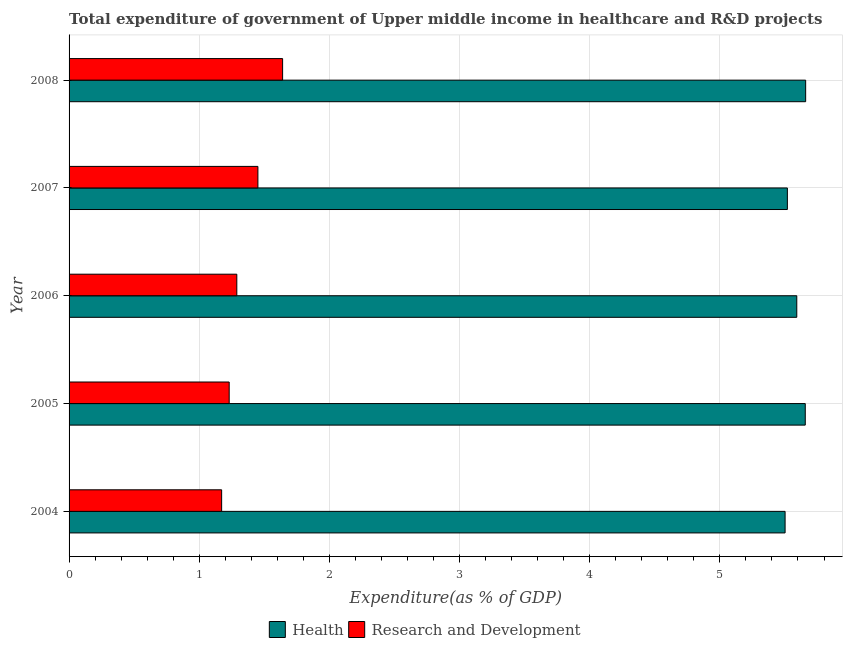Are the number of bars on each tick of the Y-axis equal?
Your answer should be compact. Yes. How many bars are there on the 3rd tick from the bottom?
Ensure brevity in your answer.  2. What is the expenditure in healthcare in 2006?
Ensure brevity in your answer.  5.59. Across all years, what is the maximum expenditure in r&d?
Offer a very short reply. 1.64. Across all years, what is the minimum expenditure in healthcare?
Give a very brief answer. 5.5. What is the total expenditure in r&d in the graph?
Ensure brevity in your answer.  6.78. What is the difference between the expenditure in r&d in 2006 and that in 2007?
Offer a very short reply. -0.16. What is the difference between the expenditure in r&d in 2008 and the expenditure in healthcare in 2007?
Your answer should be compact. -3.88. What is the average expenditure in r&d per year?
Make the answer very short. 1.36. In the year 2008, what is the difference between the expenditure in healthcare and expenditure in r&d?
Your answer should be very brief. 4.02. Is the expenditure in healthcare in 2004 less than that in 2006?
Your answer should be very brief. Yes. Is the difference between the expenditure in r&d in 2004 and 2006 greater than the difference between the expenditure in healthcare in 2004 and 2006?
Ensure brevity in your answer.  No. What is the difference between the highest and the second highest expenditure in healthcare?
Your answer should be compact. 0. What is the difference between the highest and the lowest expenditure in r&d?
Make the answer very short. 0.47. Is the sum of the expenditure in healthcare in 2005 and 2008 greater than the maximum expenditure in r&d across all years?
Provide a short and direct response. Yes. What does the 1st bar from the top in 2004 represents?
Give a very brief answer. Research and Development. What does the 2nd bar from the bottom in 2008 represents?
Give a very brief answer. Research and Development. How many bars are there?
Keep it short and to the point. 10. Are the values on the major ticks of X-axis written in scientific E-notation?
Make the answer very short. No. Where does the legend appear in the graph?
Keep it short and to the point. Bottom center. How many legend labels are there?
Your answer should be very brief. 2. How are the legend labels stacked?
Offer a terse response. Horizontal. What is the title of the graph?
Your response must be concise. Total expenditure of government of Upper middle income in healthcare and R&D projects. What is the label or title of the X-axis?
Your response must be concise. Expenditure(as % of GDP). What is the label or title of the Y-axis?
Provide a succinct answer. Year. What is the Expenditure(as % of GDP) in Health in 2004?
Your answer should be compact. 5.5. What is the Expenditure(as % of GDP) in Research and Development in 2004?
Provide a succinct answer. 1.17. What is the Expenditure(as % of GDP) in Health in 2005?
Offer a very short reply. 5.66. What is the Expenditure(as % of GDP) of Research and Development in 2005?
Offer a very short reply. 1.23. What is the Expenditure(as % of GDP) in Health in 2006?
Make the answer very short. 5.59. What is the Expenditure(as % of GDP) in Research and Development in 2006?
Provide a short and direct response. 1.29. What is the Expenditure(as % of GDP) of Health in 2007?
Provide a short and direct response. 5.52. What is the Expenditure(as % of GDP) in Research and Development in 2007?
Ensure brevity in your answer.  1.45. What is the Expenditure(as % of GDP) of Health in 2008?
Provide a short and direct response. 5.66. What is the Expenditure(as % of GDP) of Research and Development in 2008?
Make the answer very short. 1.64. Across all years, what is the maximum Expenditure(as % of GDP) in Health?
Your answer should be compact. 5.66. Across all years, what is the maximum Expenditure(as % of GDP) in Research and Development?
Your answer should be compact. 1.64. Across all years, what is the minimum Expenditure(as % of GDP) of Health?
Offer a very short reply. 5.5. Across all years, what is the minimum Expenditure(as % of GDP) in Research and Development?
Ensure brevity in your answer.  1.17. What is the total Expenditure(as % of GDP) in Health in the graph?
Make the answer very short. 27.93. What is the total Expenditure(as % of GDP) in Research and Development in the graph?
Give a very brief answer. 6.78. What is the difference between the Expenditure(as % of GDP) in Health in 2004 and that in 2005?
Your response must be concise. -0.15. What is the difference between the Expenditure(as % of GDP) of Research and Development in 2004 and that in 2005?
Provide a succinct answer. -0.06. What is the difference between the Expenditure(as % of GDP) of Health in 2004 and that in 2006?
Provide a succinct answer. -0.09. What is the difference between the Expenditure(as % of GDP) of Research and Development in 2004 and that in 2006?
Give a very brief answer. -0.12. What is the difference between the Expenditure(as % of GDP) in Health in 2004 and that in 2007?
Provide a succinct answer. -0.02. What is the difference between the Expenditure(as % of GDP) of Research and Development in 2004 and that in 2007?
Give a very brief answer. -0.28. What is the difference between the Expenditure(as % of GDP) of Health in 2004 and that in 2008?
Offer a very short reply. -0.16. What is the difference between the Expenditure(as % of GDP) in Research and Development in 2004 and that in 2008?
Your answer should be compact. -0.47. What is the difference between the Expenditure(as % of GDP) of Health in 2005 and that in 2006?
Offer a terse response. 0.07. What is the difference between the Expenditure(as % of GDP) of Research and Development in 2005 and that in 2006?
Offer a terse response. -0.06. What is the difference between the Expenditure(as % of GDP) in Health in 2005 and that in 2007?
Make the answer very short. 0.14. What is the difference between the Expenditure(as % of GDP) in Research and Development in 2005 and that in 2007?
Offer a terse response. -0.22. What is the difference between the Expenditure(as % of GDP) in Health in 2005 and that in 2008?
Make the answer very short. -0. What is the difference between the Expenditure(as % of GDP) of Research and Development in 2005 and that in 2008?
Keep it short and to the point. -0.41. What is the difference between the Expenditure(as % of GDP) of Health in 2006 and that in 2007?
Make the answer very short. 0.07. What is the difference between the Expenditure(as % of GDP) of Research and Development in 2006 and that in 2007?
Provide a succinct answer. -0.16. What is the difference between the Expenditure(as % of GDP) in Health in 2006 and that in 2008?
Your response must be concise. -0.07. What is the difference between the Expenditure(as % of GDP) in Research and Development in 2006 and that in 2008?
Ensure brevity in your answer.  -0.35. What is the difference between the Expenditure(as % of GDP) of Health in 2007 and that in 2008?
Provide a succinct answer. -0.14. What is the difference between the Expenditure(as % of GDP) of Research and Development in 2007 and that in 2008?
Make the answer very short. -0.19. What is the difference between the Expenditure(as % of GDP) in Health in 2004 and the Expenditure(as % of GDP) in Research and Development in 2005?
Offer a terse response. 4.27. What is the difference between the Expenditure(as % of GDP) of Health in 2004 and the Expenditure(as % of GDP) of Research and Development in 2006?
Ensure brevity in your answer.  4.21. What is the difference between the Expenditure(as % of GDP) in Health in 2004 and the Expenditure(as % of GDP) in Research and Development in 2007?
Offer a very short reply. 4.05. What is the difference between the Expenditure(as % of GDP) in Health in 2004 and the Expenditure(as % of GDP) in Research and Development in 2008?
Offer a terse response. 3.86. What is the difference between the Expenditure(as % of GDP) of Health in 2005 and the Expenditure(as % of GDP) of Research and Development in 2006?
Offer a very short reply. 4.37. What is the difference between the Expenditure(as % of GDP) of Health in 2005 and the Expenditure(as % of GDP) of Research and Development in 2007?
Ensure brevity in your answer.  4.21. What is the difference between the Expenditure(as % of GDP) in Health in 2005 and the Expenditure(as % of GDP) in Research and Development in 2008?
Your response must be concise. 4.02. What is the difference between the Expenditure(as % of GDP) of Health in 2006 and the Expenditure(as % of GDP) of Research and Development in 2007?
Your answer should be compact. 4.14. What is the difference between the Expenditure(as % of GDP) of Health in 2006 and the Expenditure(as % of GDP) of Research and Development in 2008?
Provide a short and direct response. 3.95. What is the difference between the Expenditure(as % of GDP) in Health in 2007 and the Expenditure(as % of GDP) in Research and Development in 2008?
Your answer should be compact. 3.88. What is the average Expenditure(as % of GDP) of Health per year?
Keep it short and to the point. 5.58. What is the average Expenditure(as % of GDP) in Research and Development per year?
Offer a very short reply. 1.36. In the year 2004, what is the difference between the Expenditure(as % of GDP) of Health and Expenditure(as % of GDP) of Research and Development?
Offer a terse response. 4.33. In the year 2005, what is the difference between the Expenditure(as % of GDP) of Health and Expenditure(as % of GDP) of Research and Development?
Give a very brief answer. 4.43. In the year 2006, what is the difference between the Expenditure(as % of GDP) of Health and Expenditure(as % of GDP) of Research and Development?
Your answer should be very brief. 4.3. In the year 2007, what is the difference between the Expenditure(as % of GDP) of Health and Expenditure(as % of GDP) of Research and Development?
Provide a short and direct response. 4.07. In the year 2008, what is the difference between the Expenditure(as % of GDP) of Health and Expenditure(as % of GDP) of Research and Development?
Your response must be concise. 4.02. What is the ratio of the Expenditure(as % of GDP) in Health in 2004 to that in 2005?
Provide a short and direct response. 0.97. What is the ratio of the Expenditure(as % of GDP) of Research and Development in 2004 to that in 2005?
Offer a very short reply. 0.95. What is the ratio of the Expenditure(as % of GDP) in Health in 2004 to that in 2006?
Your answer should be compact. 0.98. What is the ratio of the Expenditure(as % of GDP) of Research and Development in 2004 to that in 2006?
Make the answer very short. 0.91. What is the ratio of the Expenditure(as % of GDP) in Research and Development in 2004 to that in 2007?
Keep it short and to the point. 0.81. What is the ratio of the Expenditure(as % of GDP) of Health in 2004 to that in 2008?
Provide a short and direct response. 0.97. What is the ratio of the Expenditure(as % of GDP) of Research and Development in 2004 to that in 2008?
Your response must be concise. 0.71. What is the ratio of the Expenditure(as % of GDP) in Health in 2005 to that in 2006?
Provide a succinct answer. 1.01. What is the ratio of the Expenditure(as % of GDP) in Research and Development in 2005 to that in 2006?
Your response must be concise. 0.95. What is the ratio of the Expenditure(as % of GDP) of Health in 2005 to that in 2007?
Ensure brevity in your answer.  1.02. What is the ratio of the Expenditure(as % of GDP) in Research and Development in 2005 to that in 2007?
Give a very brief answer. 0.85. What is the ratio of the Expenditure(as % of GDP) in Health in 2005 to that in 2008?
Your answer should be very brief. 1. What is the ratio of the Expenditure(as % of GDP) of Research and Development in 2005 to that in 2008?
Keep it short and to the point. 0.75. What is the ratio of the Expenditure(as % of GDP) of Health in 2006 to that in 2007?
Make the answer very short. 1.01. What is the ratio of the Expenditure(as % of GDP) in Research and Development in 2006 to that in 2007?
Make the answer very short. 0.89. What is the ratio of the Expenditure(as % of GDP) of Health in 2006 to that in 2008?
Your answer should be compact. 0.99. What is the ratio of the Expenditure(as % of GDP) in Research and Development in 2006 to that in 2008?
Give a very brief answer. 0.79. What is the ratio of the Expenditure(as % of GDP) of Health in 2007 to that in 2008?
Offer a terse response. 0.98. What is the ratio of the Expenditure(as % of GDP) in Research and Development in 2007 to that in 2008?
Give a very brief answer. 0.88. What is the difference between the highest and the second highest Expenditure(as % of GDP) of Health?
Your response must be concise. 0. What is the difference between the highest and the second highest Expenditure(as % of GDP) of Research and Development?
Your answer should be very brief. 0.19. What is the difference between the highest and the lowest Expenditure(as % of GDP) in Health?
Ensure brevity in your answer.  0.16. What is the difference between the highest and the lowest Expenditure(as % of GDP) in Research and Development?
Your answer should be compact. 0.47. 